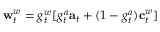<formula> <loc_0><loc_0><loc_500><loc_500>w _ { t } ^ { w } = g _ { t } ^ { w } [ g _ { t } ^ { a } a _ { t } + ( 1 - g _ { t } ^ { a } ) c _ { t } ^ { w } ]</formula> 